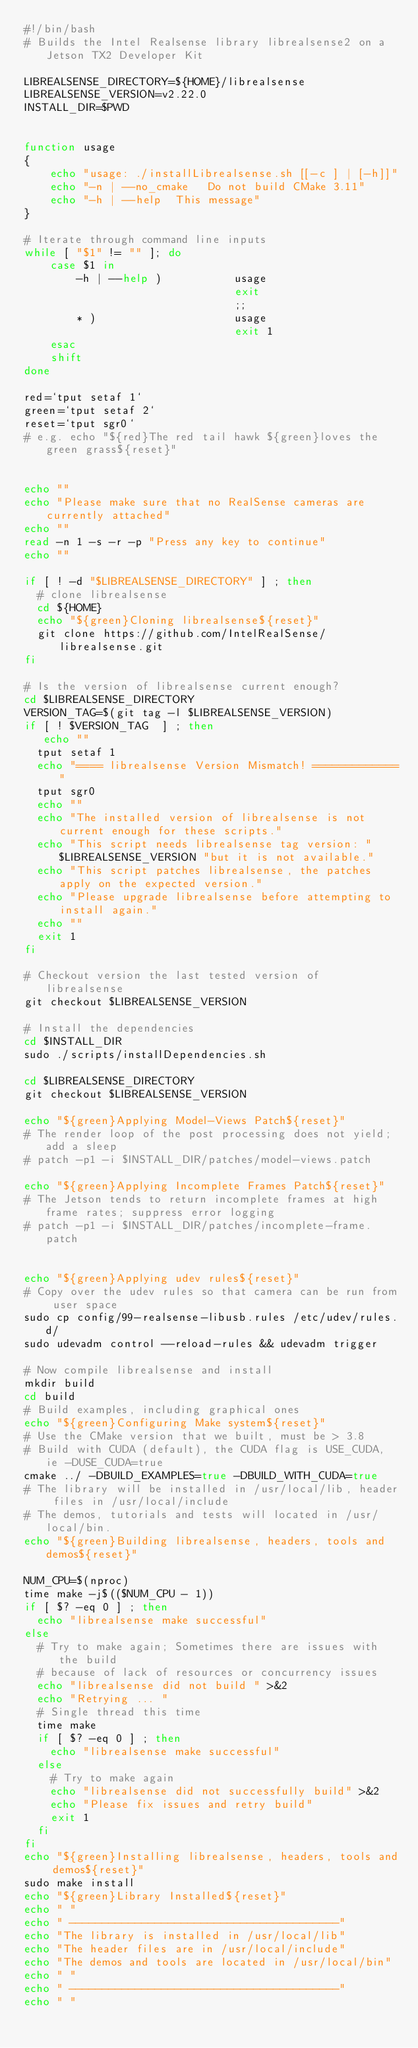Convert code to text. <code><loc_0><loc_0><loc_500><loc_500><_Bash_>#!/bin/bash
# Builds the Intel Realsense library librealsense2 on a Jetson TX2 Developer Kit

LIBREALSENSE_DIRECTORY=${HOME}/librealsense
LIBREALSENSE_VERSION=v2.22.0
INSTALL_DIR=$PWD


function usage
{
    echo "usage: ./installLibrealsense.sh [[-c ] | [-h]]"
    echo "-n | --no_cmake   Do not build CMake 3.11"
    echo "-h | --help  This message"
}

# Iterate through command line inputs
while [ "$1" != "" ]; do
    case $1 in
        -h | --help )           usage
                                exit
                                ;;
        * )                     usage
                                exit 1
    esac
    shift
done

red=`tput setaf 1`
green=`tput setaf 2`
reset=`tput sgr0`
# e.g. echo "${red}The red tail hawk ${green}loves the green grass${reset}"


echo ""
echo "Please make sure that no RealSense cameras are currently attached"
echo ""
read -n 1 -s -r -p "Press any key to continue"
echo ""

if [ ! -d "$LIBREALSENSE_DIRECTORY" ] ; then
  # clone librealsense
  cd ${HOME}
  echo "${green}Cloning librealsense${reset}"
  git clone https://github.com/IntelRealSense/librealsense.git
fi

# Is the version of librealsense current enough?
cd $LIBREALSENSE_DIRECTORY
VERSION_TAG=$(git tag -l $LIBREALSENSE_VERSION)
if [ ! $VERSION_TAG  ] ; then
   echo ""
  tput setaf 1
  echo "==== librealsense Version Mismatch! ============="
  tput sgr0
  echo ""
  echo "The installed version of librealsense is not current enough for these scripts."
  echo "This script needs librealsense tag version: "$LIBREALSENSE_VERSION "but it is not available."
  echo "This script patches librealsense, the patches apply on the expected version."
  echo "Please upgrade librealsense before attempting to install again."
  echo ""
  exit 1
fi

# Checkout version the last tested version of librealsense
git checkout $LIBREALSENSE_VERSION

# Install the dependencies
cd $INSTALL_DIR
sudo ./scripts/installDependencies.sh

cd $LIBREALSENSE_DIRECTORY
git checkout $LIBREALSENSE_VERSION

echo "${green}Applying Model-Views Patch${reset}"
# The render loop of the post processing does not yield; add a sleep
# patch -p1 -i $INSTALL_DIR/patches/model-views.patch

echo "${green}Applying Incomplete Frames Patch${reset}"
# The Jetson tends to return incomplete frames at high frame rates; suppress error logging
# patch -p1 -i $INSTALL_DIR/patches/incomplete-frame.patch


echo "${green}Applying udev rules${reset}"
# Copy over the udev rules so that camera can be run from user space
sudo cp config/99-realsense-libusb.rules /etc/udev/rules.d/
sudo udevadm control --reload-rules && udevadm trigger

# Now compile librealsense and install
mkdir build 
cd build
# Build examples, including graphical ones
echo "${green}Configuring Make system${reset}"
# Use the CMake version that we built, must be > 3.8
# Build with CUDA (default), the CUDA flag is USE_CUDA, ie -DUSE_CUDA=true
cmake ../ -DBUILD_EXAMPLES=true -DBUILD_WITH_CUDA=true
# The library will be installed in /usr/local/lib, header files in /usr/local/include
# The demos, tutorials and tests will located in /usr/local/bin.
echo "${green}Building librealsense, headers, tools and demos${reset}"

NUM_CPU=$(nproc)
time make -j$(($NUM_CPU - 1))
if [ $? -eq 0 ] ; then
  echo "librealsense make successful"
else
  # Try to make again; Sometimes there are issues with the build
  # because of lack of resources or concurrency issues
  echo "librealsense did not build " >&2
  echo "Retrying ... "
  # Single thread this time
  time make 
  if [ $? -eq 0 ] ; then
    echo "librealsense make successful"
  else
    # Try to make again
    echo "librealsense did not successfully build" >&2
    echo "Please fix issues and retry build"
    exit 1
  fi
fi
echo "${green}Installing librealsense, headers, tools and demos${reset}"
sudo make install
echo "${green}Library Installed${reset}"
echo " "
echo " -----------------------------------------"
echo "The library is installed in /usr/local/lib"
echo "The header files are in /usr/local/include"
echo "The demos and tools are located in /usr/local/bin"
echo " "
echo " -----------------------------------------"
echo " "



</code> 